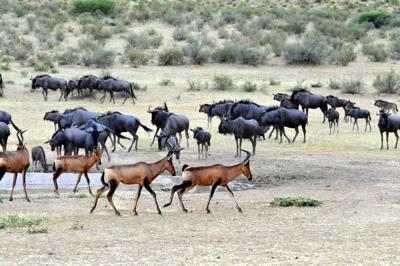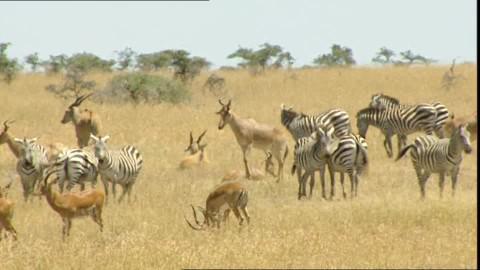The first image is the image on the left, the second image is the image on the right. For the images displayed, is the sentence "There are no more than seven animals in the image on the left." factually correct? Answer yes or no. No. 